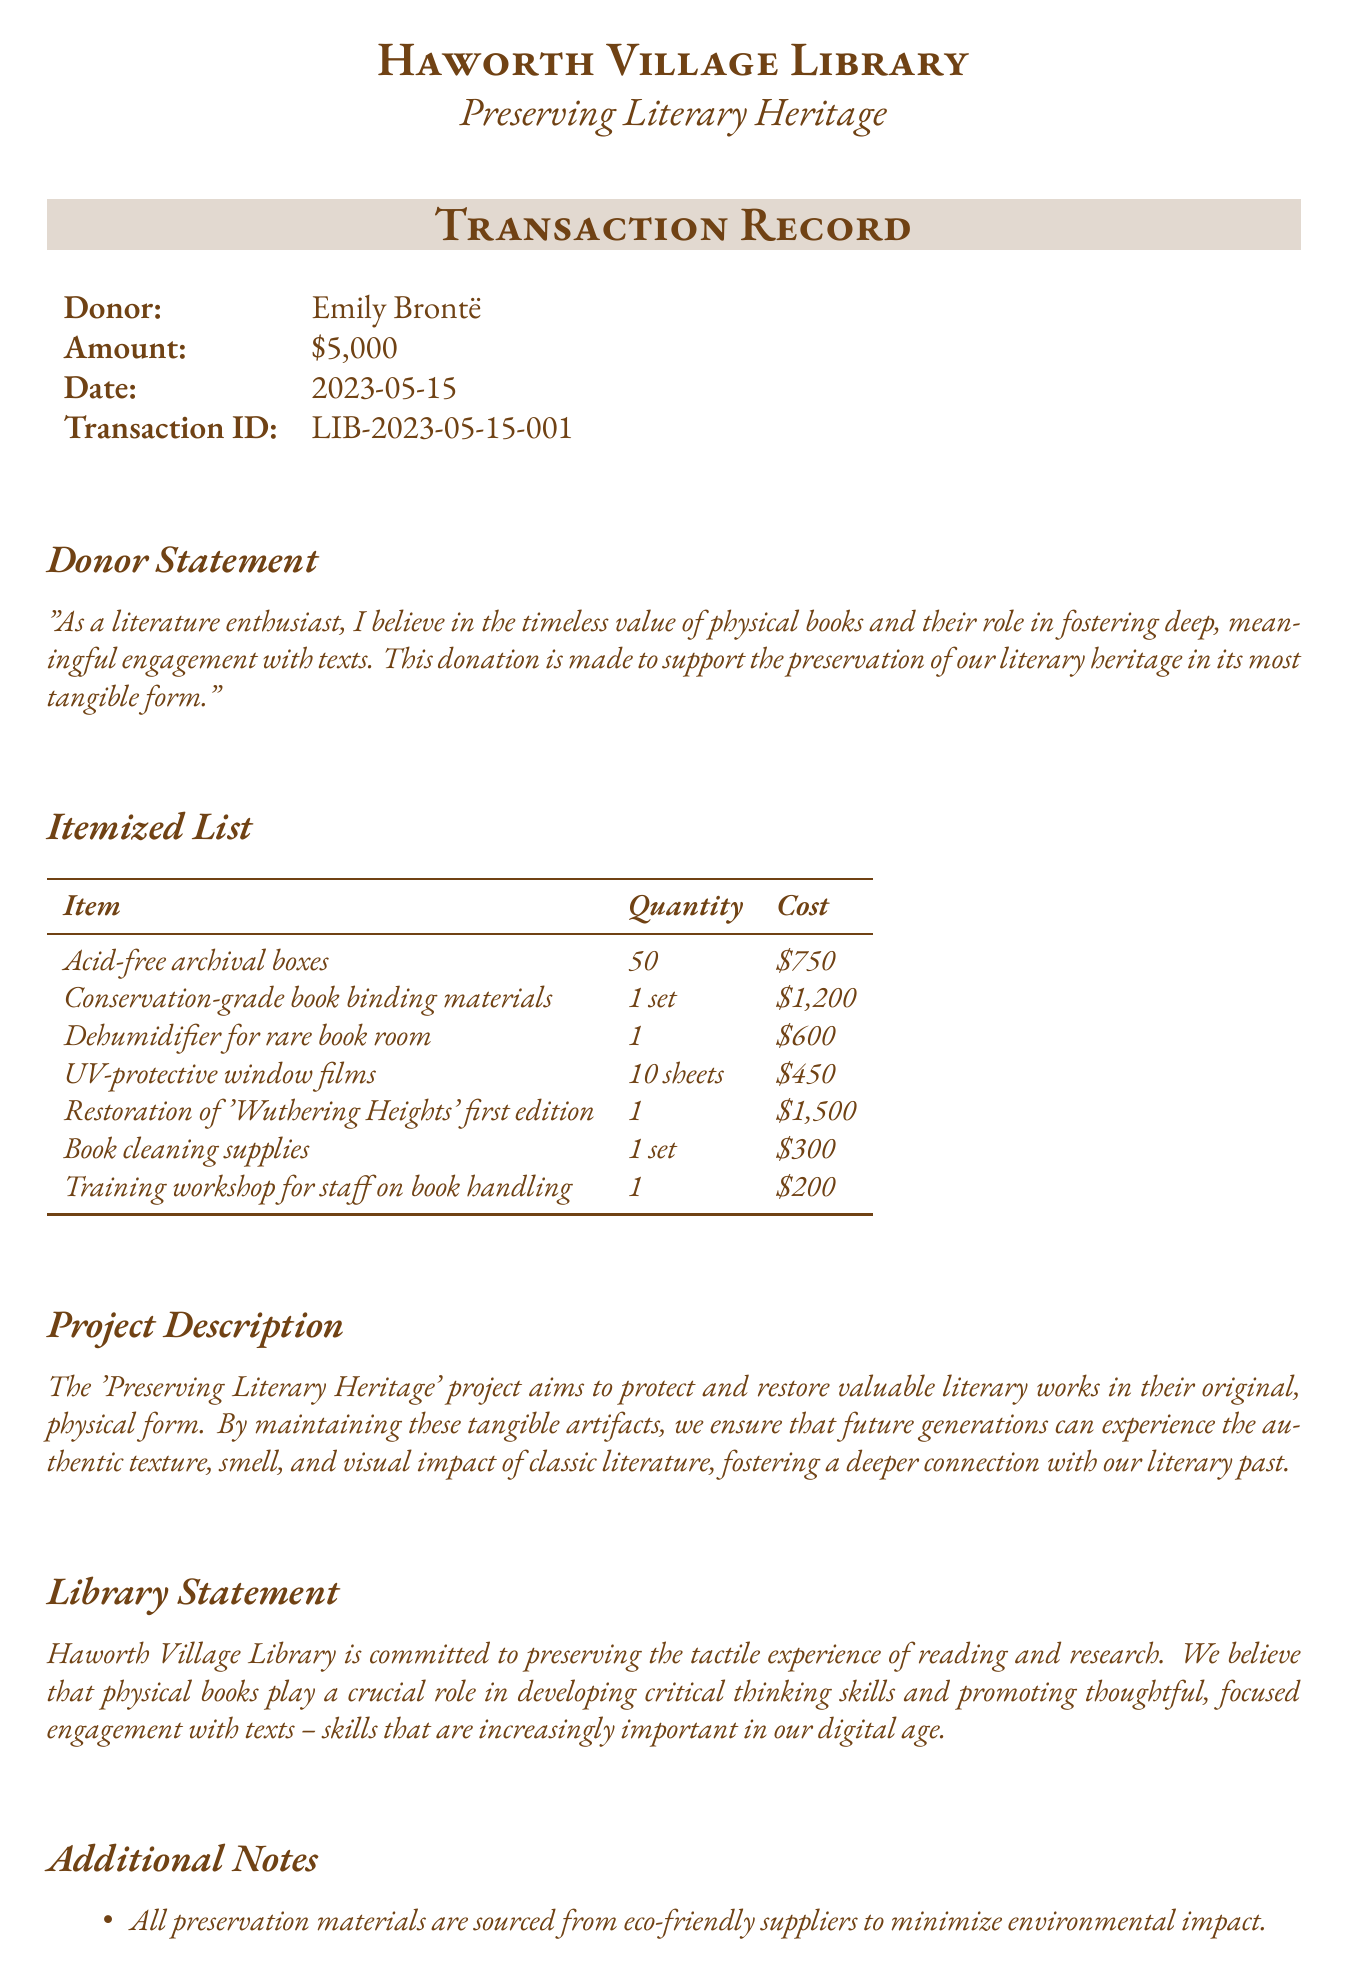What is the donation amount? The donation amount is stated in the transaction details, which shows a total of $5,000.
Answer: $5,000 Who is the donor? The donor's name is provided in the transaction details, which lists Emily Brontë as the donor.
Answer: Emily Brontë What project is being funded? The project name is mentioned in the transaction details as "Preserving Literary Heritage."
Answer: Preserving Literary Heritage How many acid-free archival boxes are being purchased? The itemized list specifies the quantity of acid-free archival boxes as 50.
Answer: 50 What is the cost for the restoration of 'Wuthering Heights' first edition? The itemized list includes the cost for this specific restoration, which is $1,500.
Answer: $1,500 What is the purpose of the technology-free reading room? The additional notes outline the intention of this room as a means to foster distraction-free reading experiences.
Answer: Encourage distraction-free, immersive reading experiences What will the training workshop for staff focus on? The itemized list indicates that the workshop will focus on book handling.
Answer: Book handling What materials are used for preservation? The additional notes mention that all preservation materials are sourced from eco-friendly suppliers.
Answer: Eco-friendly suppliers When was the transaction made? The date of the transaction is noted in the document as 2023-05-15.
Answer: 2023-05-15 